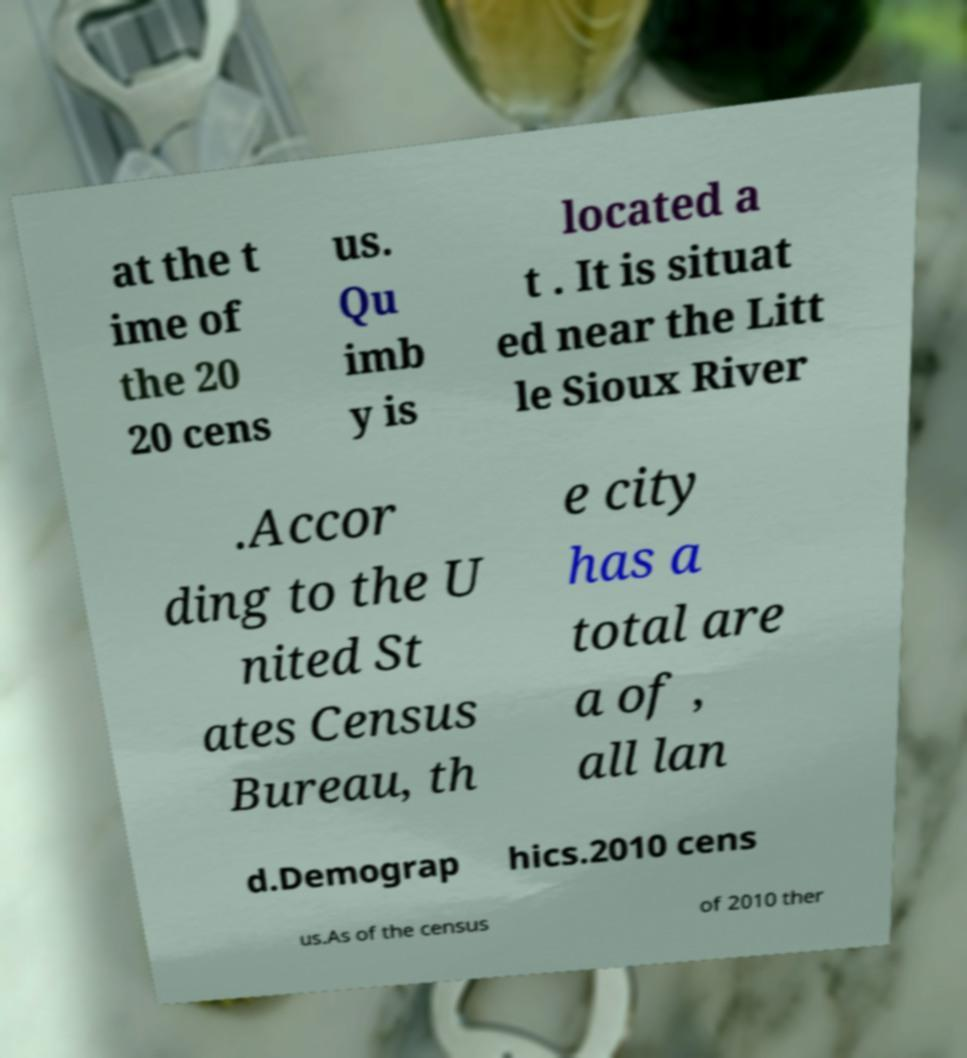Please identify and transcribe the text found in this image. at the t ime of the 20 20 cens us. Qu imb y is located a t . It is situat ed near the Litt le Sioux River .Accor ding to the U nited St ates Census Bureau, th e city has a total are a of , all lan d.Demograp hics.2010 cens us.As of the census of 2010 ther 